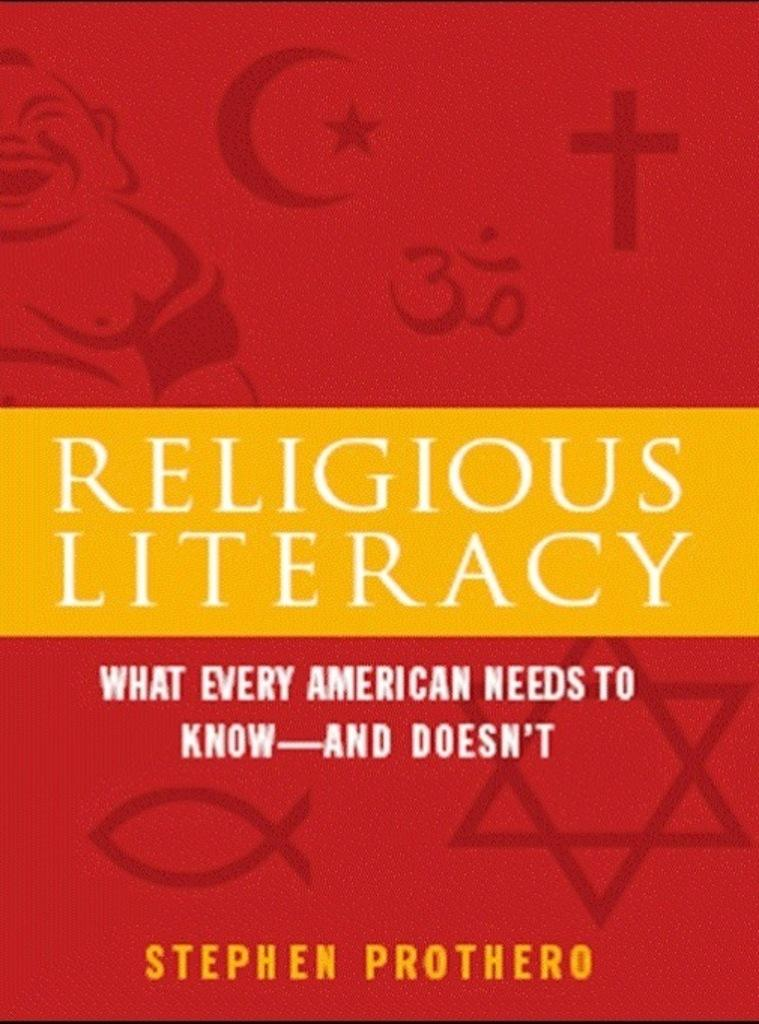<image>
Write a terse but informative summary of the picture. A Stephen Prothero book about religious literacy has a red cover with religious symbols all over it. 